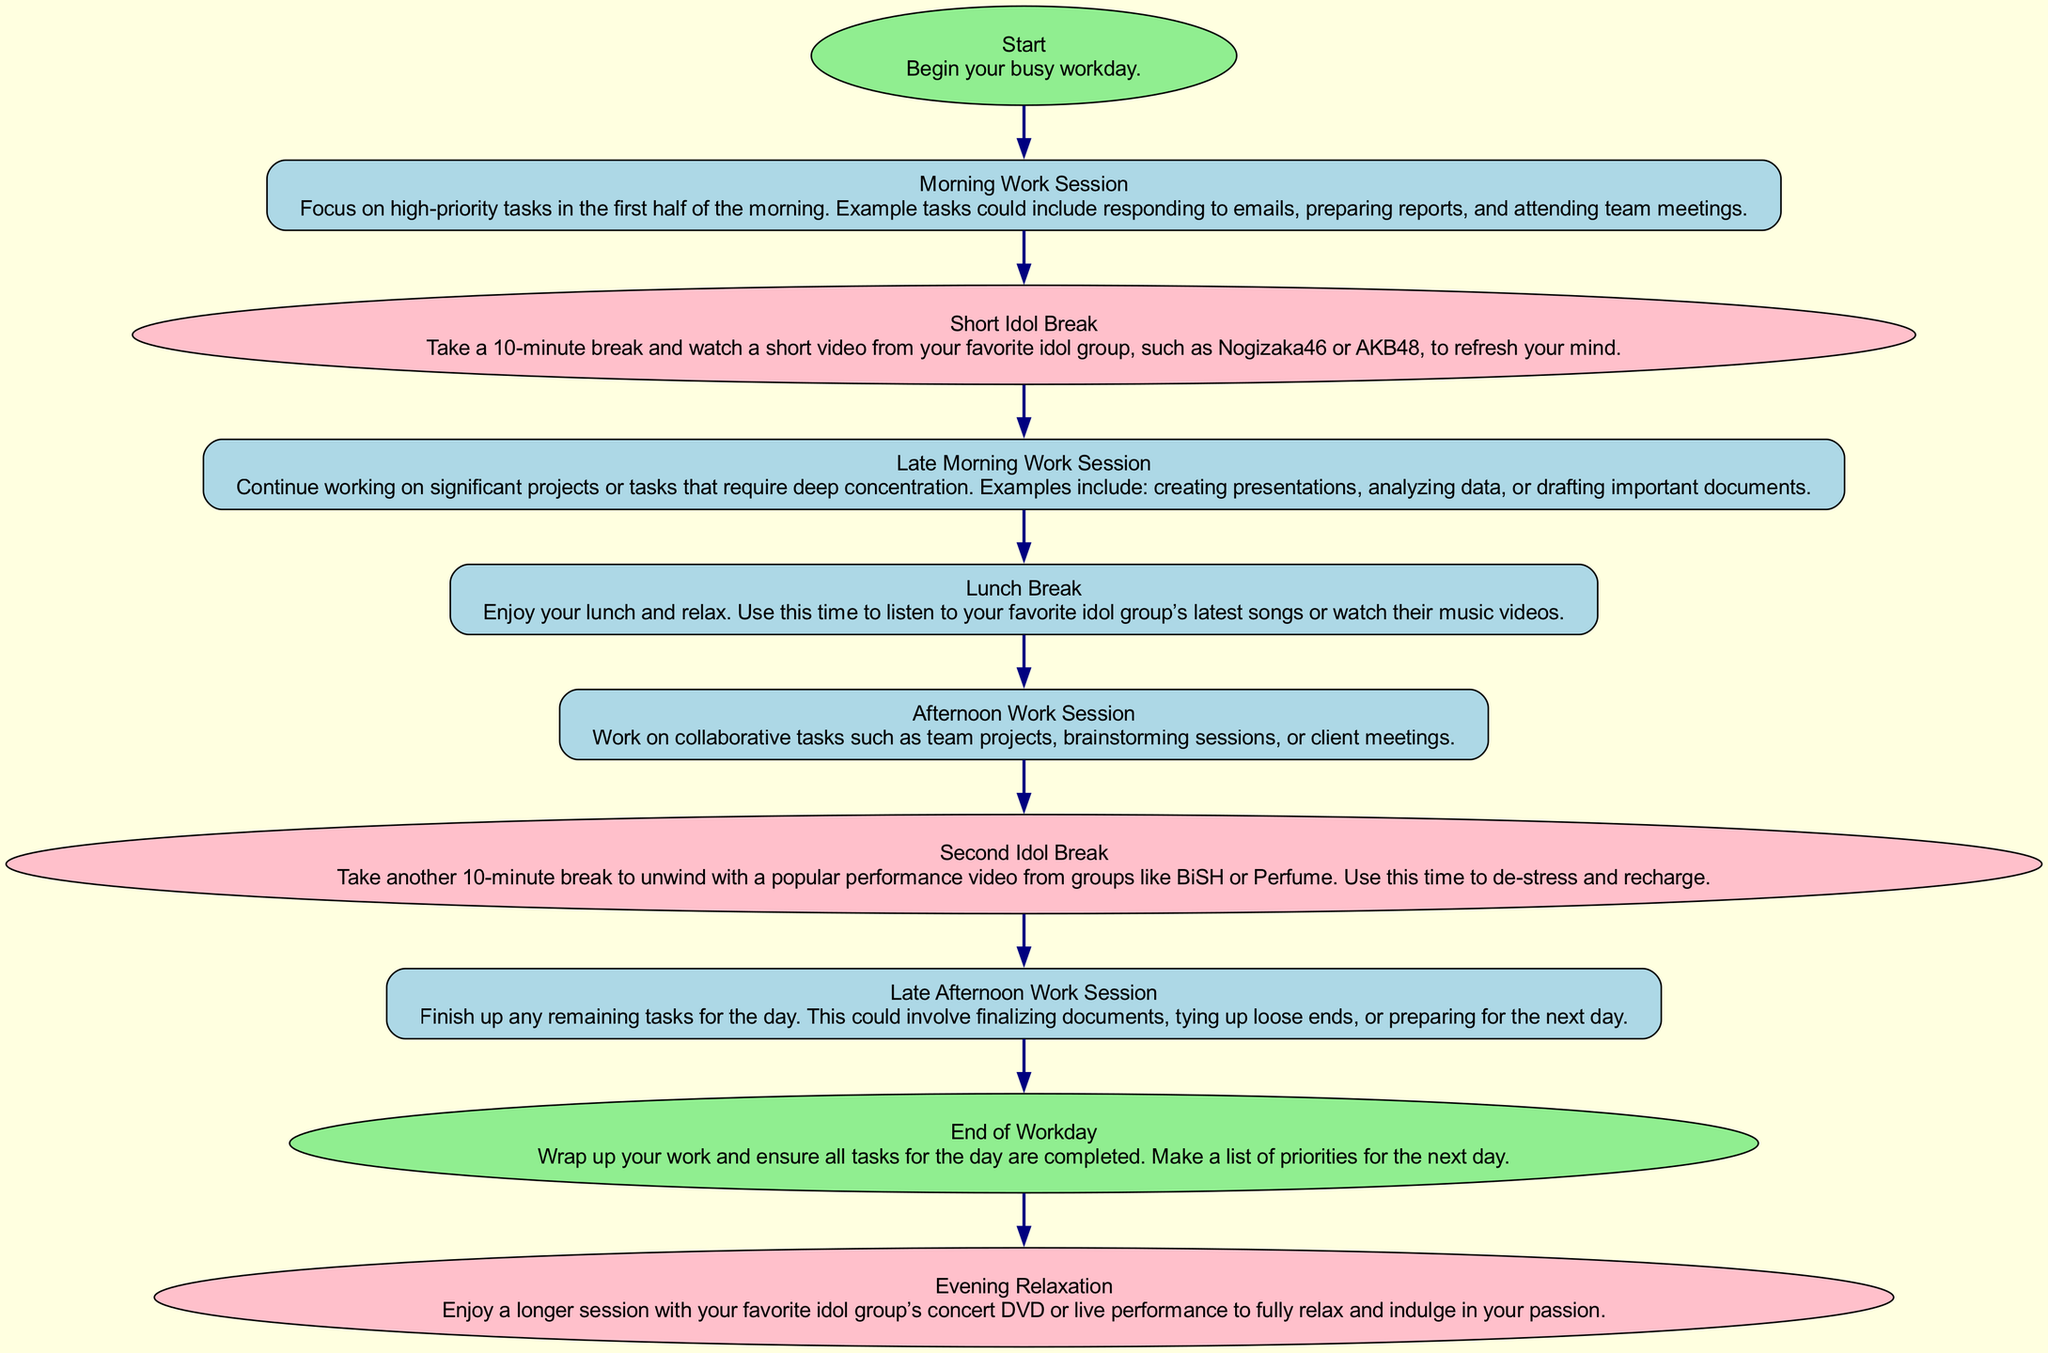What is the first step in organizing a busy workday? The first step is indicated by the 'Start' node, which states "Begin your busy workday." This is the initial action that sets the day in motion.
Answer: Start How many idol breaks are included in the schedule? The diagram includes two idol breaks as indicated by 'Short Idol Break' and 'Second Idol Break' nodes. Each break serves to refresh and recharge.
Answer: 2 What activity is suggested during the Lunch Break? According to the 'Lunch Break' node, the recommendation is to "Enjoy your lunch and relax" and also to use this time for listening to idol songs or watching music videos.
Answer: Listening to idol songs or watching music videos Which work session follows the first 'Idol Break'? The flow chart shows that after the 'Short Idol Break,' the next session is the 'Late Morning Work Session.' This indicates a continuation of work after the break.
Answer: Late Morning Work Session How many total nodes are in the diagram? Counting all the elements in the provided data, there are ten nodes, which include steps from "Start" to "Evening Relaxation." Each represents a stage in the busy workday organization.
Answer: 10 What does the 'Evening Relaxation' node suggest? According to the diagram, the 'Evening Relaxation' node suggests indulging in a longer session with your favorite idol group's concert DVD or live performance to unwind fully.
Answer: Enjoy a longer session with your favorite idol group’s concert DVD or live performance What type of task is emphasized in the 'Afternoon Work Session'? The 'Afternoon Work Session' focuses on tasks that require collaboration, such as team projects and client meetings, as indicated in its description.
Answer: Collaborative tasks Which node highlights a task requiring deep concentration? The 'Late Morning Work Session' emphasizes tasks that require deep concentration, such as analyzing data and drafting important documents, as stated in the diagram.
Answer: Late Morning Work Session What is the purpose of the 'Second Idol Break'? The 'Second Idol Break' serves to de-stress and recharge, where one unwinds with a popular performance video, as indicated in its description.
Answer: To de-stress and recharge 